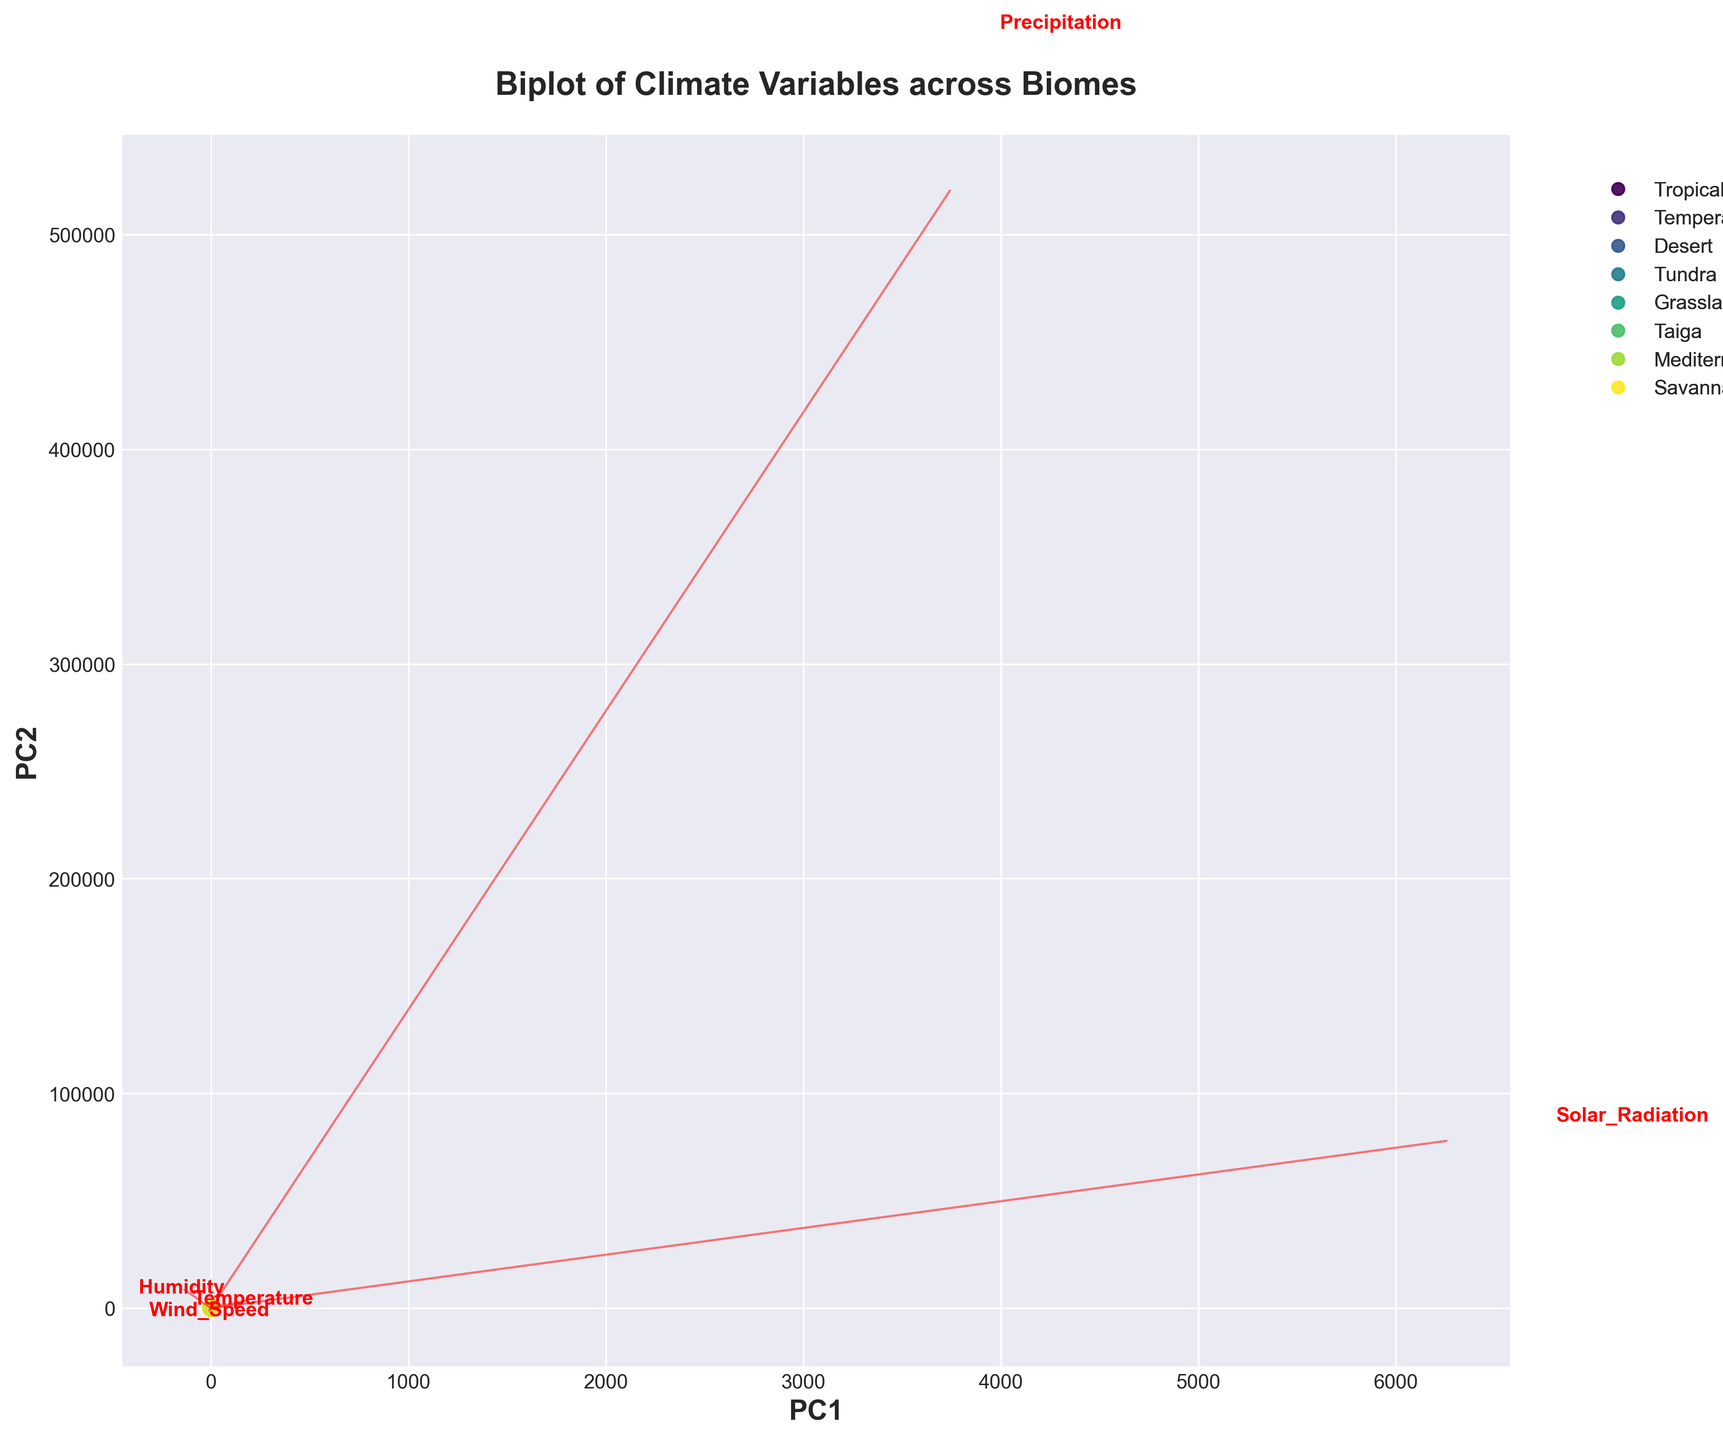how many biomes are represented in the biplot? The title of the plot mentions "Climate Variables across Biomes". Observing the scatter plot, each biome is represented by a distinct color, and the legend indicates these biomes. Counting the unique entries in the legend, there are 8 biomes.
Answer: 8 Which biome is closest to the center of the plot? Observing the scatter plot, the center is located at the point (0,0) on the PC1 and PC2 axes. The biome closest to this center point appears to be the Mediterranean.
Answer: Mediterranean What climate variable has the largest positive influence on PC1? The eigenvectors represented by red arrows indicate the influence of climate variables. The arrow that points farthest along the positive PC1 axis is for Wind Speed. This suggests that Wind Speed has the largest positive influence on PC1.
Answer: Wind Speed Which biomes have a high PC1 score but a low PC2 score? Observing the scatter plot, biomes positioned towards the right (positive PC1 values) but towards the bottom (negative PC2 values) are Desert and Tundra.
Answer: Desert and Tundra Which biome appears to have both high Temperature and high Solar Radiation based on its position in the biplot? The arrows for Temperature and Solar Radiation point in similar directions. The biome located in the same direction but farthest from the center in this direction is the Desert biome.
Answer: Desert What can you infer about the relationship between Humidity and Temperature from the plot? Observing the red arrows, the direction of Humidity is almost opposite to Temperature. This suggests an inverse relationship; as Humidity increases, Temperature tends to decrease, and vice versa.
Answer: Inverse relationship Which biome has the lowest Humidity based on the biplot? Following the red arrow labeled "Humidity" towards its negative direction on PC1 and PC2, the closest biome to this low Humidity position is the Desert.
Answer: Desert What is the main contributing variable for the high PC2 score of the Tropical Rainforest biome? Observing the plot, the Tropical Rainforest biome scores high on PC2, and the red arrow closest in direction to this biome is Humidity. This indicates that Humidity is a major contributing factor.
Answer: Humidity Which two biomes are closest to each other in the biplot? Looking at the scatter plot, Temperate Deciduous Forest and Taiga are the closest data points, indicating similar climatic characteristics in terms of PC1 and PC2.
Answer: Temperate Deciduous Forest and Taiga 